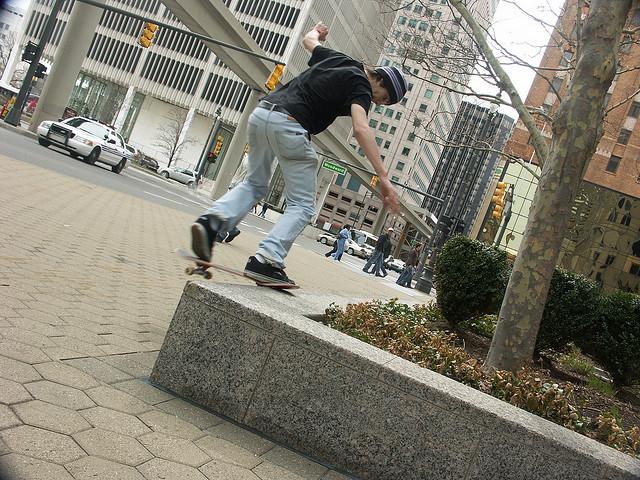Is this image urban or rural?
Short answer required. Urban. What is the boy riding?
Give a very brief answer. Skateboard. Is the man wearing jeans?
Keep it brief. Yes. 